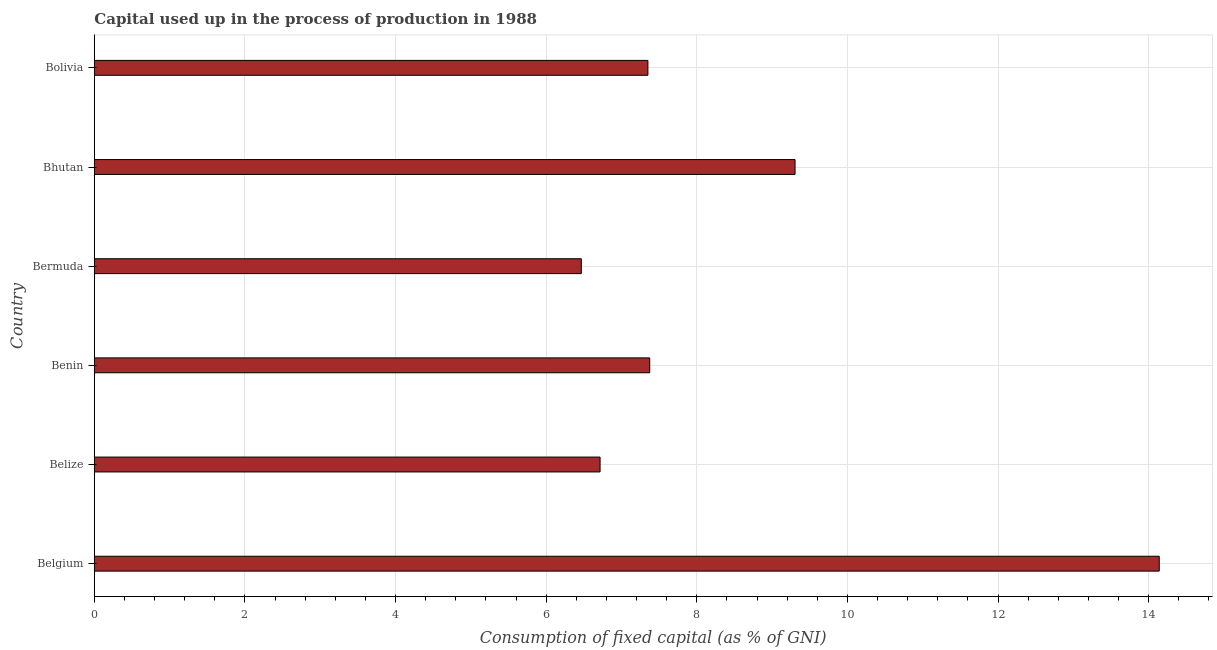Does the graph contain any zero values?
Keep it short and to the point. No. Does the graph contain grids?
Your response must be concise. Yes. What is the title of the graph?
Provide a succinct answer. Capital used up in the process of production in 1988. What is the label or title of the X-axis?
Your answer should be very brief. Consumption of fixed capital (as % of GNI). What is the consumption of fixed capital in Belize?
Offer a very short reply. 6.72. Across all countries, what is the maximum consumption of fixed capital?
Your answer should be very brief. 14.14. Across all countries, what is the minimum consumption of fixed capital?
Offer a very short reply. 6.47. In which country was the consumption of fixed capital minimum?
Make the answer very short. Bermuda. What is the sum of the consumption of fixed capital?
Provide a succinct answer. 51.35. What is the difference between the consumption of fixed capital in Bhutan and Bolivia?
Your answer should be compact. 1.95. What is the average consumption of fixed capital per country?
Offer a very short reply. 8.56. What is the median consumption of fixed capital?
Provide a succinct answer. 7.36. In how many countries, is the consumption of fixed capital greater than 13.6 %?
Make the answer very short. 1. What is the ratio of the consumption of fixed capital in Belize to that in Bhutan?
Your answer should be very brief. 0.72. What is the difference between the highest and the second highest consumption of fixed capital?
Provide a succinct answer. 4.84. What is the difference between the highest and the lowest consumption of fixed capital?
Make the answer very short. 7.67. In how many countries, is the consumption of fixed capital greater than the average consumption of fixed capital taken over all countries?
Your answer should be very brief. 2. How many bars are there?
Give a very brief answer. 6. Are all the bars in the graph horizontal?
Your answer should be compact. Yes. What is the difference between two consecutive major ticks on the X-axis?
Your answer should be compact. 2. What is the Consumption of fixed capital (as % of GNI) of Belgium?
Keep it short and to the point. 14.14. What is the Consumption of fixed capital (as % of GNI) in Belize?
Your answer should be compact. 6.72. What is the Consumption of fixed capital (as % of GNI) in Benin?
Offer a terse response. 7.37. What is the Consumption of fixed capital (as % of GNI) of Bermuda?
Your answer should be very brief. 6.47. What is the Consumption of fixed capital (as % of GNI) of Bhutan?
Offer a terse response. 9.3. What is the Consumption of fixed capital (as % of GNI) of Bolivia?
Offer a very short reply. 7.35. What is the difference between the Consumption of fixed capital (as % of GNI) in Belgium and Belize?
Give a very brief answer. 7.43. What is the difference between the Consumption of fixed capital (as % of GNI) in Belgium and Benin?
Your answer should be very brief. 6.77. What is the difference between the Consumption of fixed capital (as % of GNI) in Belgium and Bermuda?
Provide a succinct answer. 7.67. What is the difference between the Consumption of fixed capital (as % of GNI) in Belgium and Bhutan?
Provide a succinct answer. 4.84. What is the difference between the Consumption of fixed capital (as % of GNI) in Belgium and Bolivia?
Your answer should be very brief. 6.79. What is the difference between the Consumption of fixed capital (as % of GNI) in Belize and Benin?
Give a very brief answer. -0.66. What is the difference between the Consumption of fixed capital (as % of GNI) in Belize and Bermuda?
Your answer should be very brief. 0.25. What is the difference between the Consumption of fixed capital (as % of GNI) in Belize and Bhutan?
Offer a very short reply. -2.59. What is the difference between the Consumption of fixed capital (as % of GNI) in Belize and Bolivia?
Your response must be concise. -0.64. What is the difference between the Consumption of fixed capital (as % of GNI) in Benin and Bermuda?
Provide a succinct answer. 0.91. What is the difference between the Consumption of fixed capital (as % of GNI) in Benin and Bhutan?
Your response must be concise. -1.93. What is the difference between the Consumption of fixed capital (as % of GNI) in Benin and Bolivia?
Your answer should be compact. 0.02. What is the difference between the Consumption of fixed capital (as % of GNI) in Bermuda and Bhutan?
Provide a short and direct response. -2.84. What is the difference between the Consumption of fixed capital (as % of GNI) in Bermuda and Bolivia?
Make the answer very short. -0.88. What is the difference between the Consumption of fixed capital (as % of GNI) in Bhutan and Bolivia?
Give a very brief answer. 1.95. What is the ratio of the Consumption of fixed capital (as % of GNI) in Belgium to that in Belize?
Your answer should be very brief. 2.11. What is the ratio of the Consumption of fixed capital (as % of GNI) in Belgium to that in Benin?
Make the answer very short. 1.92. What is the ratio of the Consumption of fixed capital (as % of GNI) in Belgium to that in Bermuda?
Make the answer very short. 2.19. What is the ratio of the Consumption of fixed capital (as % of GNI) in Belgium to that in Bhutan?
Your response must be concise. 1.52. What is the ratio of the Consumption of fixed capital (as % of GNI) in Belgium to that in Bolivia?
Offer a very short reply. 1.92. What is the ratio of the Consumption of fixed capital (as % of GNI) in Belize to that in Benin?
Offer a very short reply. 0.91. What is the ratio of the Consumption of fixed capital (as % of GNI) in Belize to that in Bermuda?
Your answer should be compact. 1.04. What is the ratio of the Consumption of fixed capital (as % of GNI) in Belize to that in Bhutan?
Provide a succinct answer. 0.72. What is the ratio of the Consumption of fixed capital (as % of GNI) in Belize to that in Bolivia?
Make the answer very short. 0.91. What is the ratio of the Consumption of fixed capital (as % of GNI) in Benin to that in Bermuda?
Keep it short and to the point. 1.14. What is the ratio of the Consumption of fixed capital (as % of GNI) in Benin to that in Bhutan?
Ensure brevity in your answer.  0.79. What is the ratio of the Consumption of fixed capital (as % of GNI) in Bermuda to that in Bhutan?
Your answer should be very brief. 0.69. What is the ratio of the Consumption of fixed capital (as % of GNI) in Bhutan to that in Bolivia?
Offer a terse response. 1.27. 